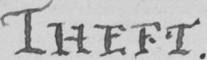Transcribe the text shown in this historical manuscript line. THEFT . 